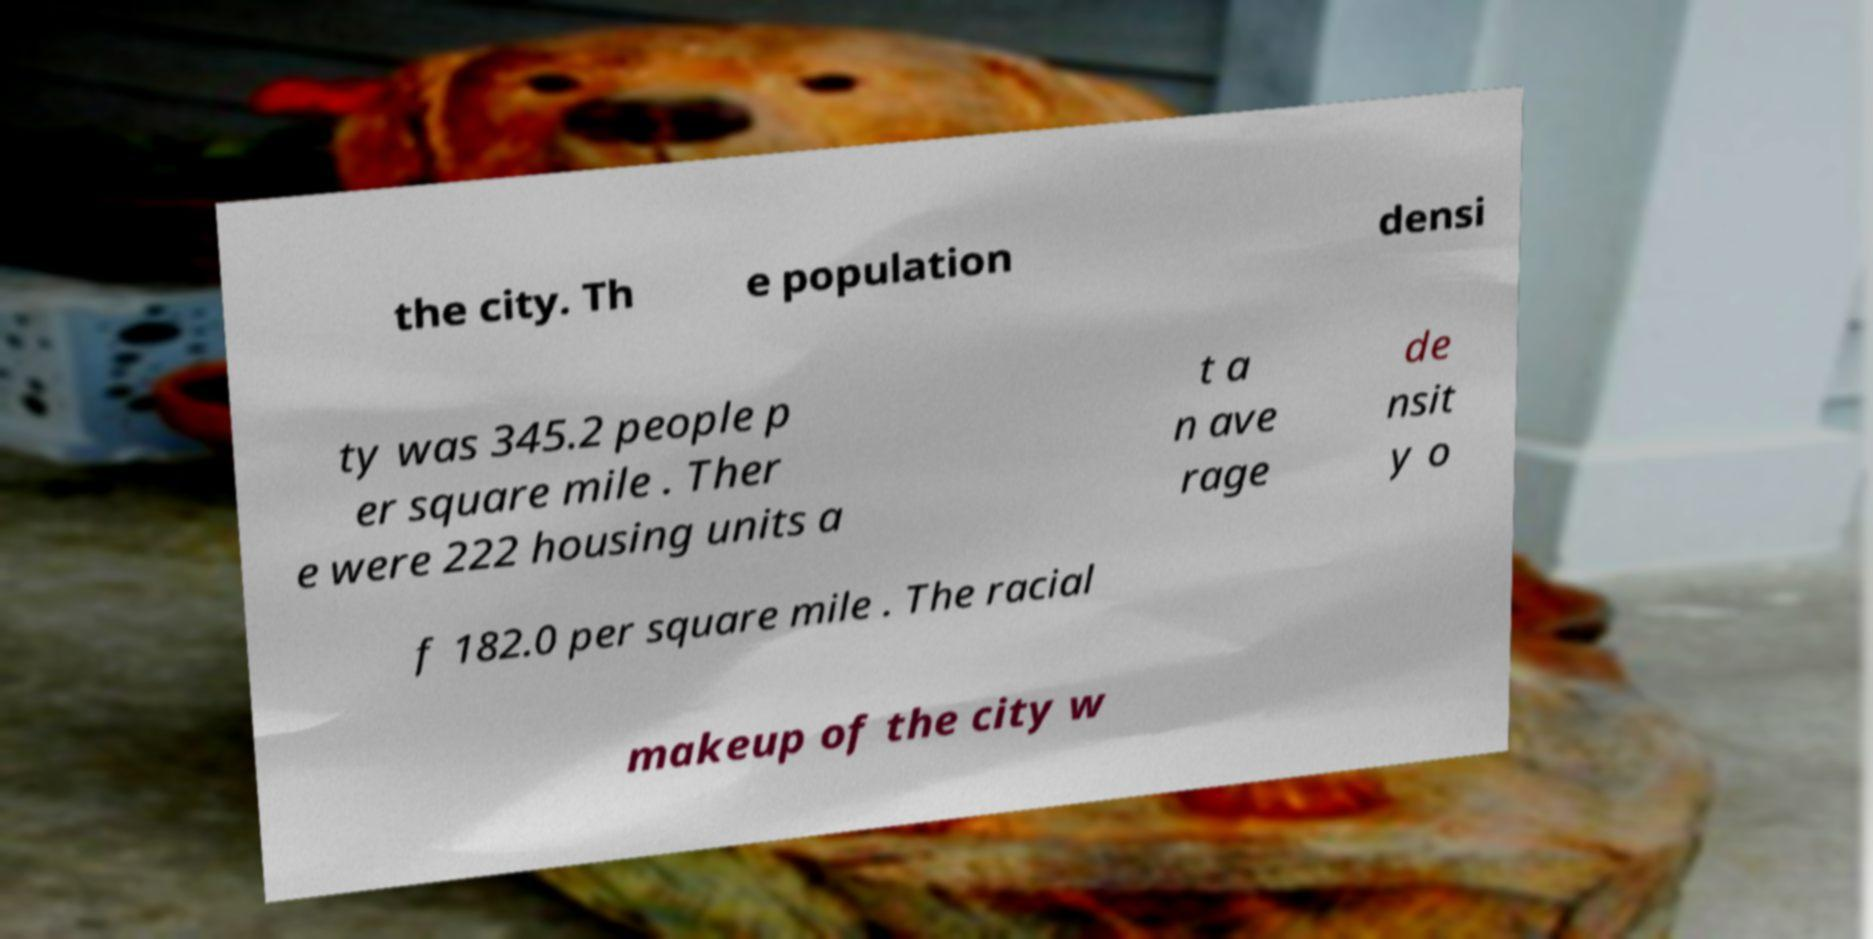Can you read and provide the text displayed in the image?This photo seems to have some interesting text. Can you extract and type it out for me? the city. Th e population densi ty was 345.2 people p er square mile . Ther e were 222 housing units a t a n ave rage de nsit y o f 182.0 per square mile . The racial makeup of the city w 